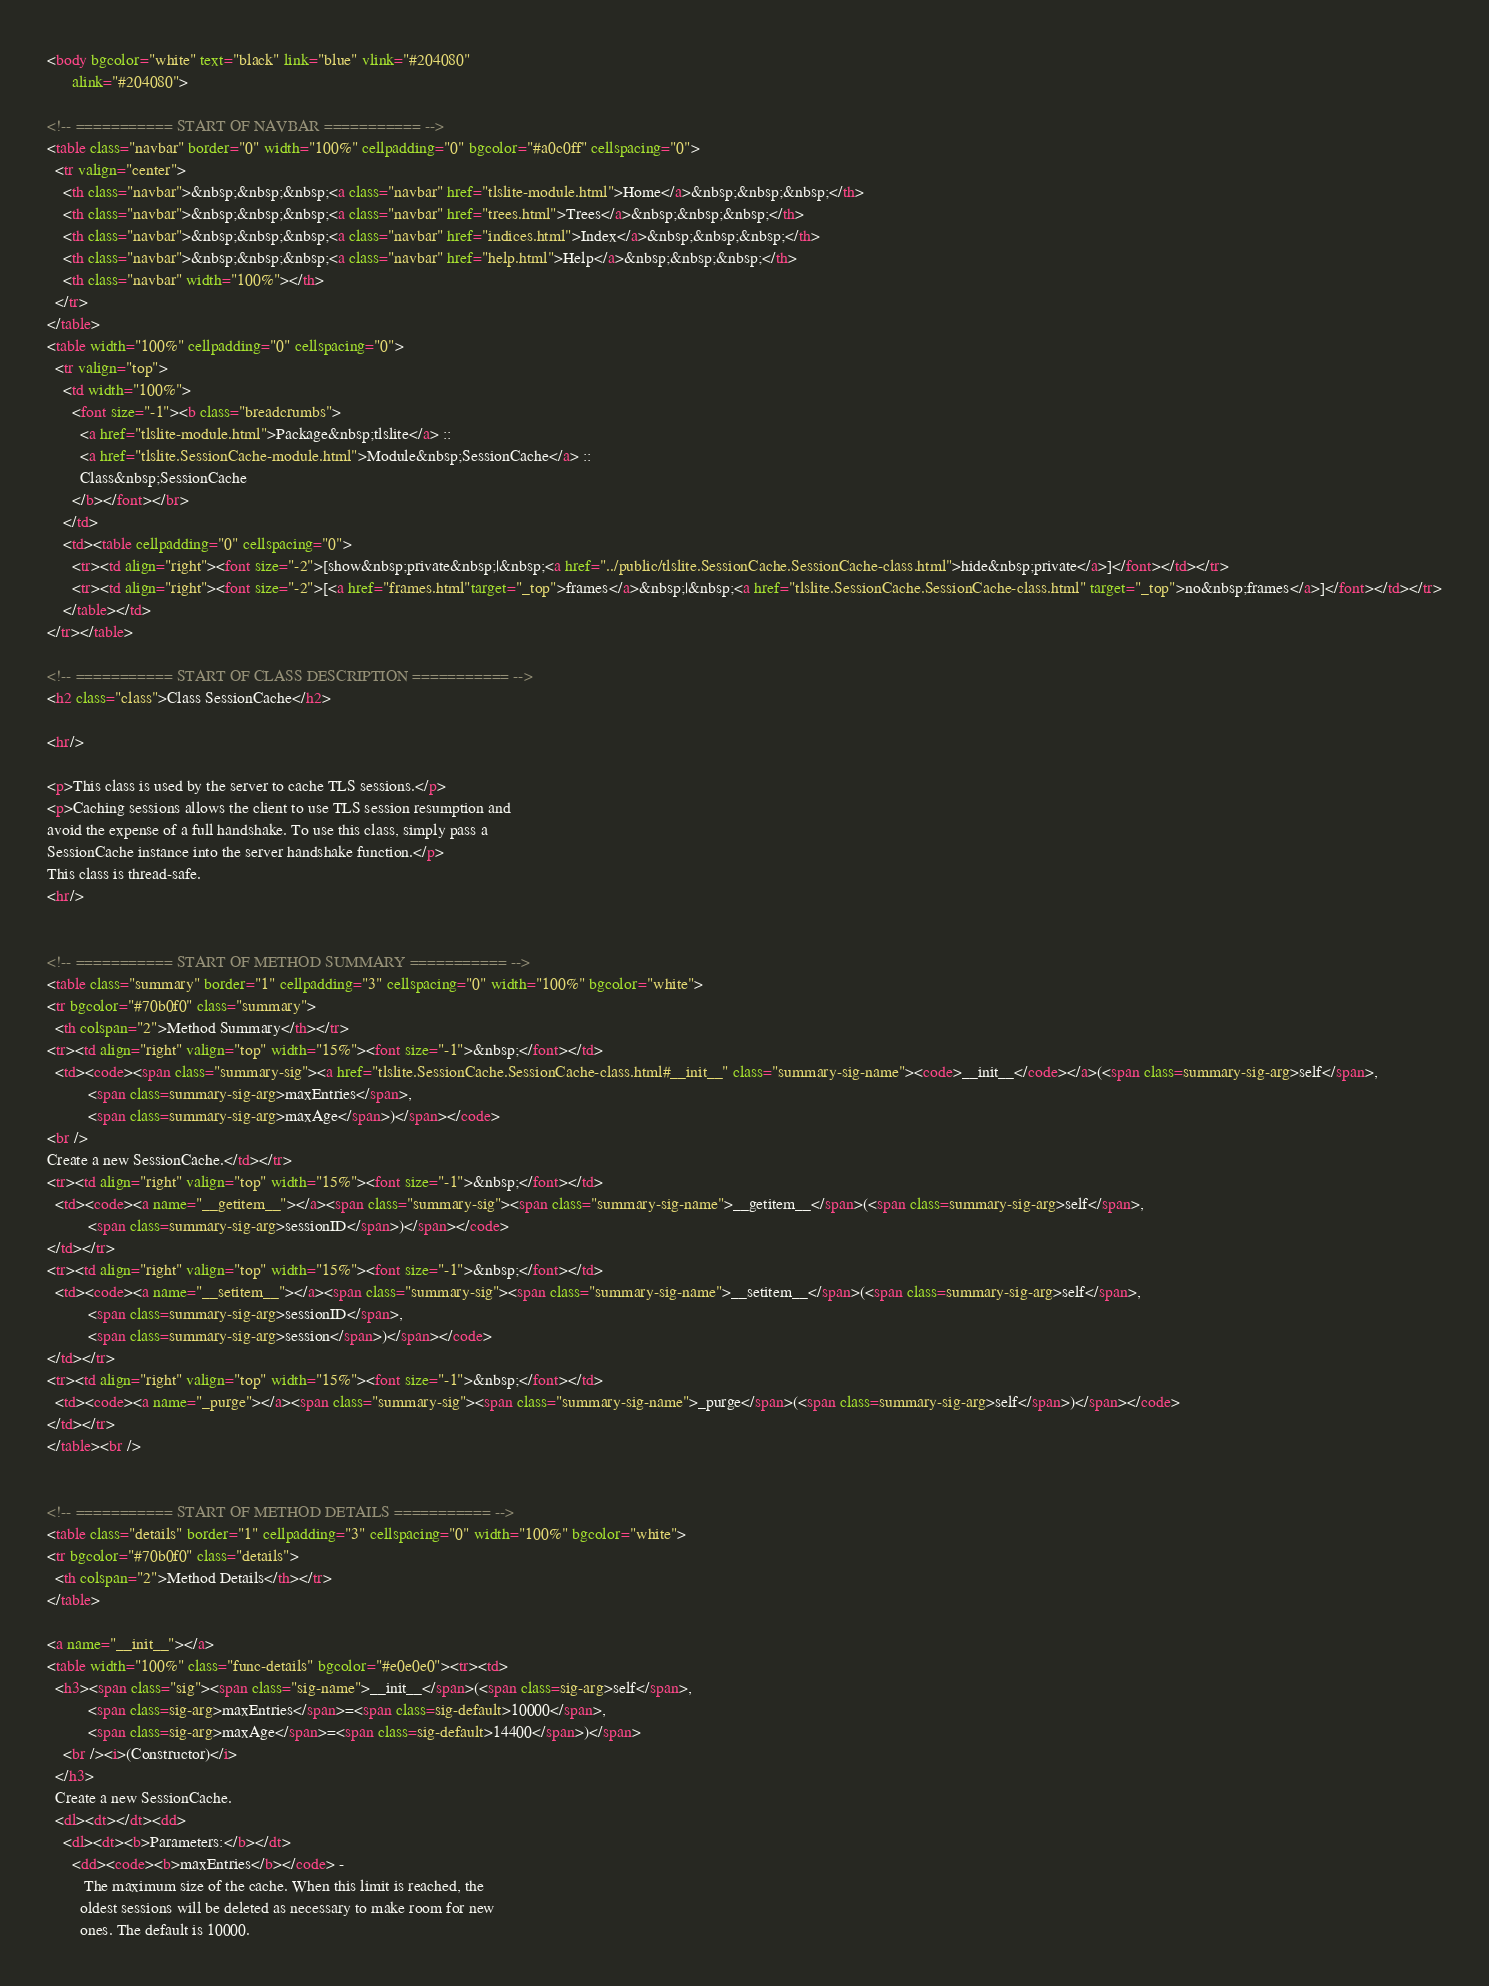<code> <loc_0><loc_0><loc_500><loc_500><_HTML_><body bgcolor="white" text="black" link="blue" vlink="#204080"
      alink="#204080">

<!-- =========== START OF NAVBAR =========== -->
<table class="navbar" border="0" width="100%" cellpadding="0" bgcolor="#a0c0ff" cellspacing="0">
  <tr valign="center">
    <th class="navbar">&nbsp;&nbsp;&nbsp;<a class="navbar" href="tlslite-module.html">Home</a>&nbsp;&nbsp;&nbsp;</th>
    <th class="navbar">&nbsp;&nbsp;&nbsp;<a class="navbar" href="trees.html">Trees</a>&nbsp;&nbsp;&nbsp;</th>
    <th class="navbar">&nbsp;&nbsp;&nbsp;<a class="navbar" href="indices.html">Index</a>&nbsp;&nbsp;&nbsp;</th>
    <th class="navbar">&nbsp;&nbsp;&nbsp;<a class="navbar" href="help.html">Help</a>&nbsp;&nbsp;&nbsp;</th>
    <th class="navbar" width="100%"></th>
  </tr>
</table>
<table width="100%" cellpadding="0" cellspacing="0">
  <tr valign="top">
    <td width="100%">
      <font size="-1"><b class="breadcrumbs">
        <a href="tlslite-module.html">Package&nbsp;tlslite</a> ::
        <a href="tlslite.SessionCache-module.html">Module&nbsp;SessionCache</a> ::
        Class&nbsp;SessionCache
      </b></font></br>
    </td>
    <td><table cellpadding="0" cellspacing="0">
      <tr><td align="right"><font size="-2">[show&nbsp;private&nbsp;|&nbsp;<a href="../public/tlslite.SessionCache.SessionCache-class.html">hide&nbsp;private</a>]</font></td></tr>
      <tr><td align="right"><font size="-2">[<a href="frames.html"target="_top">frames</a>&nbsp;|&nbsp;<a href="tlslite.SessionCache.SessionCache-class.html" target="_top">no&nbsp;frames</a>]</font></td></tr>
    </table></td>
</tr></table>

<!-- =========== START OF CLASS DESCRIPTION =========== -->
<h2 class="class">Class SessionCache</h2>

<hr/>

<p>This class is used by the server to cache TLS sessions.</p>
<p>Caching sessions allows the client to use TLS session resumption and 
avoid the expense of a full handshake. To use this class, simply pass a 
SessionCache instance into the server handshake function.</p>
This class is thread-safe.
<hr/>


<!-- =========== START OF METHOD SUMMARY =========== -->
<table class="summary" border="1" cellpadding="3" cellspacing="0" width="100%" bgcolor="white">
<tr bgcolor="#70b0f0" class="summary">
  <th colspan="2">Method Summary</th></tr>
<tr><td align="right" valign="top" width="15%"><font size="-1">&nbsp;</font></td>
  <td><code><span class="summary-sig"><a href="tlslite.SessionCache.SessionCache-class.html#__init__" class="summary-sig-name"><code>__init__</code></a>(<span class=summary-sig-arg>self</span>,
          <span class=summary-sig-arg>maxEntries</span>,
          <span class=summary-sig-arg>maxAge</span>)</span></code>
<br />
Create a new SessionCache.</td></tr>
<tr><td align="right" valign="top" width="15%"><font size="-1">&nbsp;</font></td>
  <td><code><a name="__getitem__"></a><span class="summary-sig"><span class="summary-sig-name">__getitem__</span>(<span class=summary-sig-arg>self</span>,
          <span class=summary-sig-arg>sessionID</span>)</span></code>
</td></tr>
<tr><td align="right" valign="top" width="15%"><font size="-1">&nbsp;</font></td>
  <td><code><a name="__setitem__"></a><span class="summary-sig"><span class="summary-sig-name">__setitem__</span>(<span class=summary-sig-arg>self</span>,
          <span class=summary-sig-arg>sessionID</span>,
          <span class=summary-sig-arg>session</span>)</span></code>
</td></tr>
<tr><td align="right" valign="top" width="15%"><font size="-1">&nbsp;</font></td>
  <td><code><a name="_purge"></a><span class="summary-sig"><span class="summary-sig-name">_purge</span>(<span class=summary-sig-arg>self</span>)</span></code>
</td></tr>
</table><br />


<!-- =========== START OF METHOD DETAILS =========== -->
<table class="details" border="1" cellpadding="3" cellspacing="0" width="100%" bgcolor="white">
<tr bgcolor="#70b0f0" class="details">
  <th colspan="2">Method Details</th></tr>
</table>

<a name="__init__"></a>
<table width="100%" class="func-details" bgcolor="#e0e0e0"><tr><td>
  <h3><span class="sig"><span class="sig-name">__init__</span>(<span class=sig-arg>self</span>,
          <span class=sig-arg>maxEntries</span>=<span class=sig-default>10000</span>,
          <span class=sig-arg>maxAge</span>=<span class=sig-default>14400</span>)</span>
    <br /><i>(Constructor)</i>
  </h3>
  Create a new SessionCache.
  <dl><dt></dt><dd>
    <dl><dt><b>Parameters:</b></dt>
      <dd><code><b>maxEntries</b></code> -
         The maximum size of the cache. When this limit is reached, the 
        oldest sessions will be deleted as necessary to make room for new 
        ones. The default is 10000.</code> 